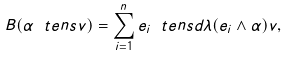Convert formula to latex. <formula><loc_0><loc_0><loc_500><loc_500>B ( \alpha \ t e n s v ) = \sum _ { i = 1 } ^ { n } e _ { i } \ t e n s d \lambda ( e _ { i } \wedge \alpha ) v ,</formula> 